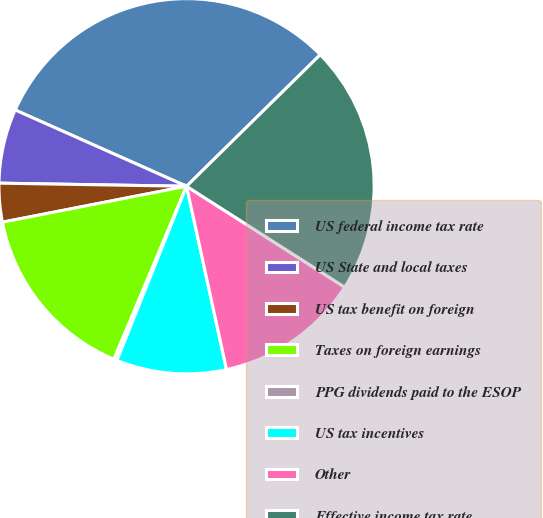Convert chart to OTSL. <chart><loc_0><loc_0><loc_500><loc_500><pie_chart><fcel>US federal income tax rate<fcel>US State and local taxes<fcel>US tax benefit on foreign<fcel>Taxes on foreign earnings<fcel>PPG dividends paid to the ESOP<fcel>US tax incentives<fcel>Other<fcel>Effective income tax rate<nl><fcel>30.96%<fcel>6.4%<fcel>3.33%<fcel>15.61%<fcel>0.27%<fcel>9.47%<fcel>12.54%<fcel>21.41%<nl></chart> 